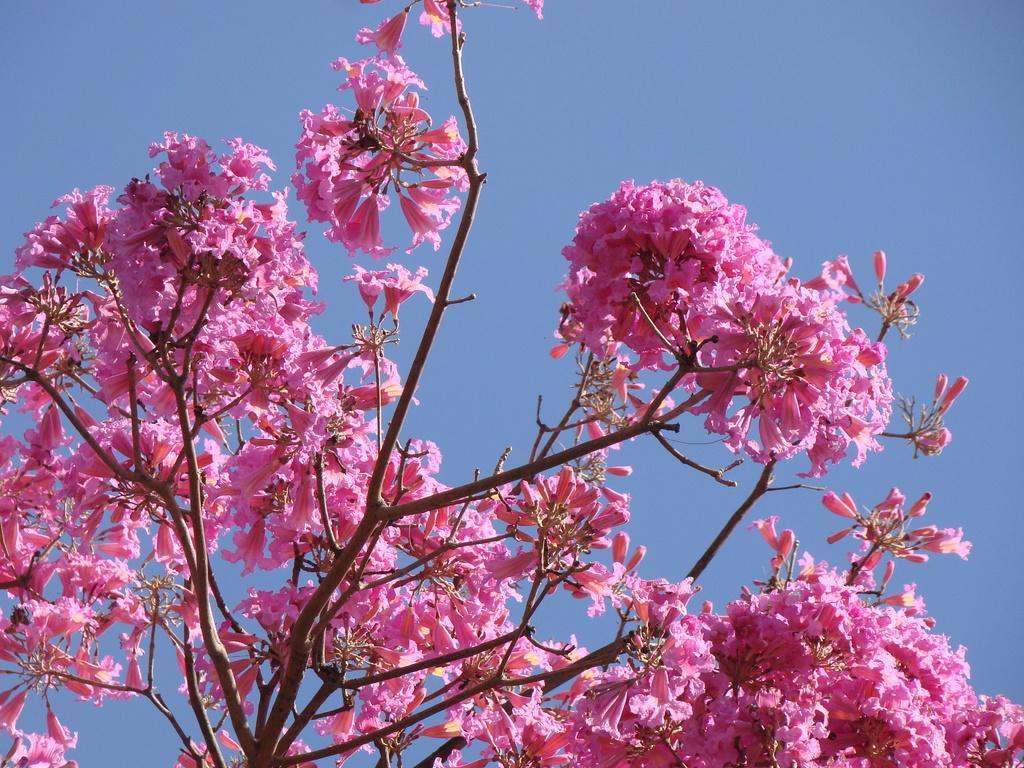Describe this image in one or two sentences. This image is taken outdoors. In the background there is a sky. In this image there is a tree with pink flowers. 